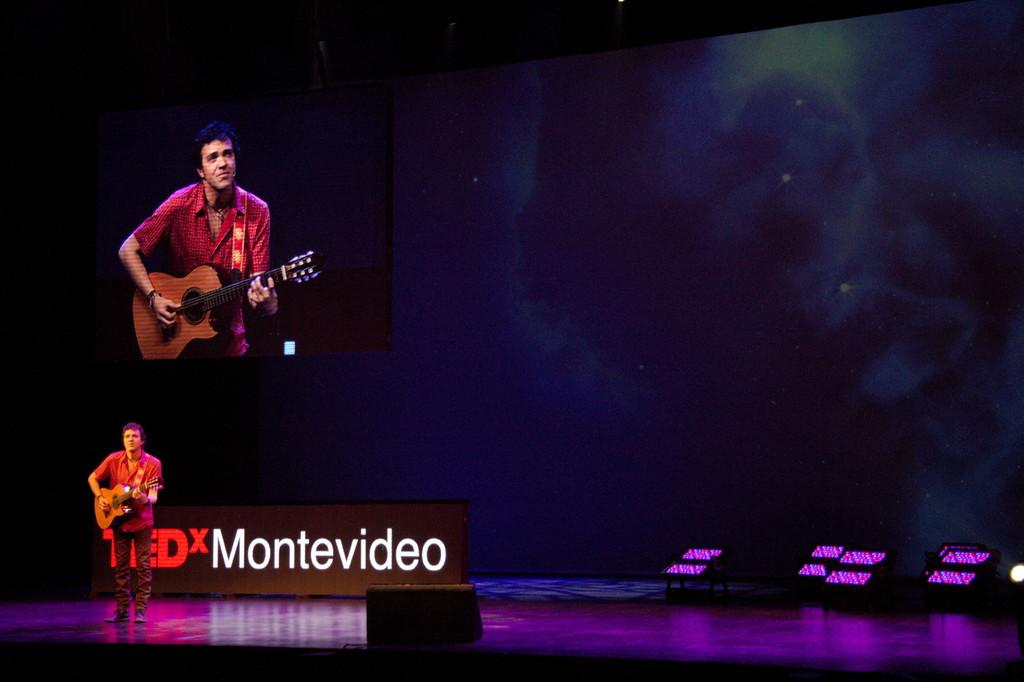What is the man in the image doing? The man is playing the guitar. What object is the man holding in the image? The man is holding a guitar. Where is the man located in the image? The man is standing on a stage. What can be seen in the background of the image? There is a screen, a wall, and lights in the background of the image. What type of toothpaste is the man using in the image? There is no toothpaste present in the image. 